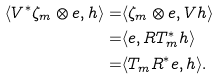<formula> <loc_0><loc_0><loc_500><loc_500>\langle V ^ { * } \zeta _ { m } \otimes e , h \rangle = & \langle \zeta _ { m } \otimes e , V h \rangle \\ = & \langle e , R T _ { m } ^ { * } h \rangle \\ = & \langle T _ { m } R ^ { * } e , h \rangle .</formula> 